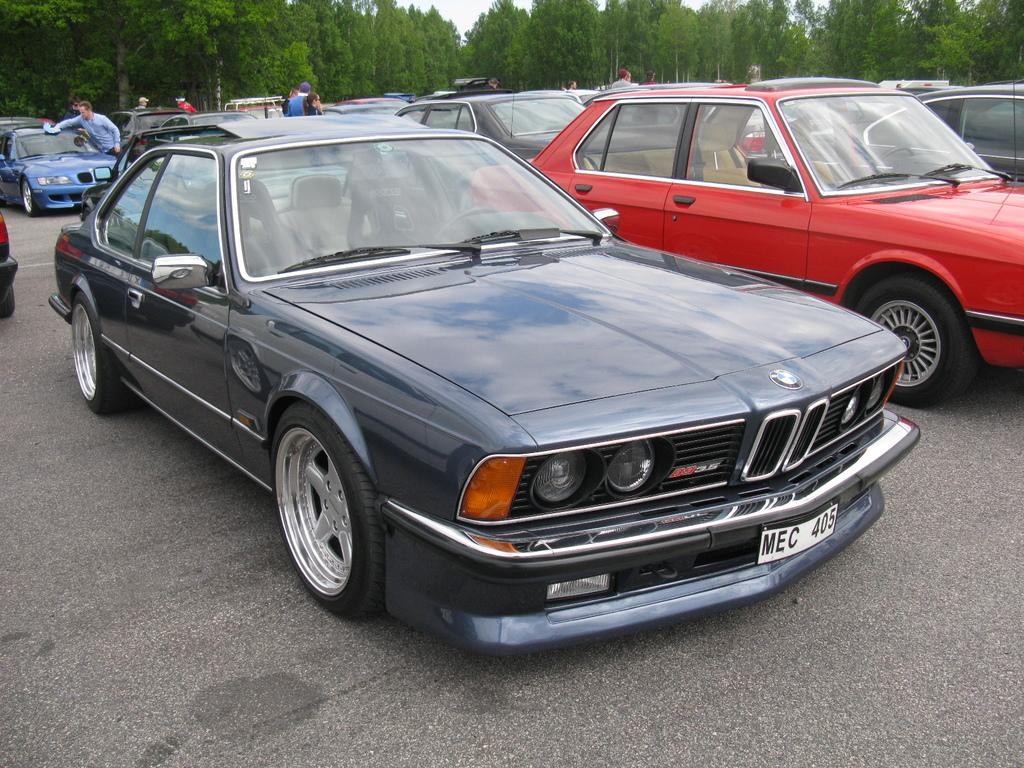What type of vehicles can be seen in the image? There are cars in the image. What is located at the top of the image? There are trees at the top of the image. How many geese are sitting on the cars in the image? There are no geese present in the image. 